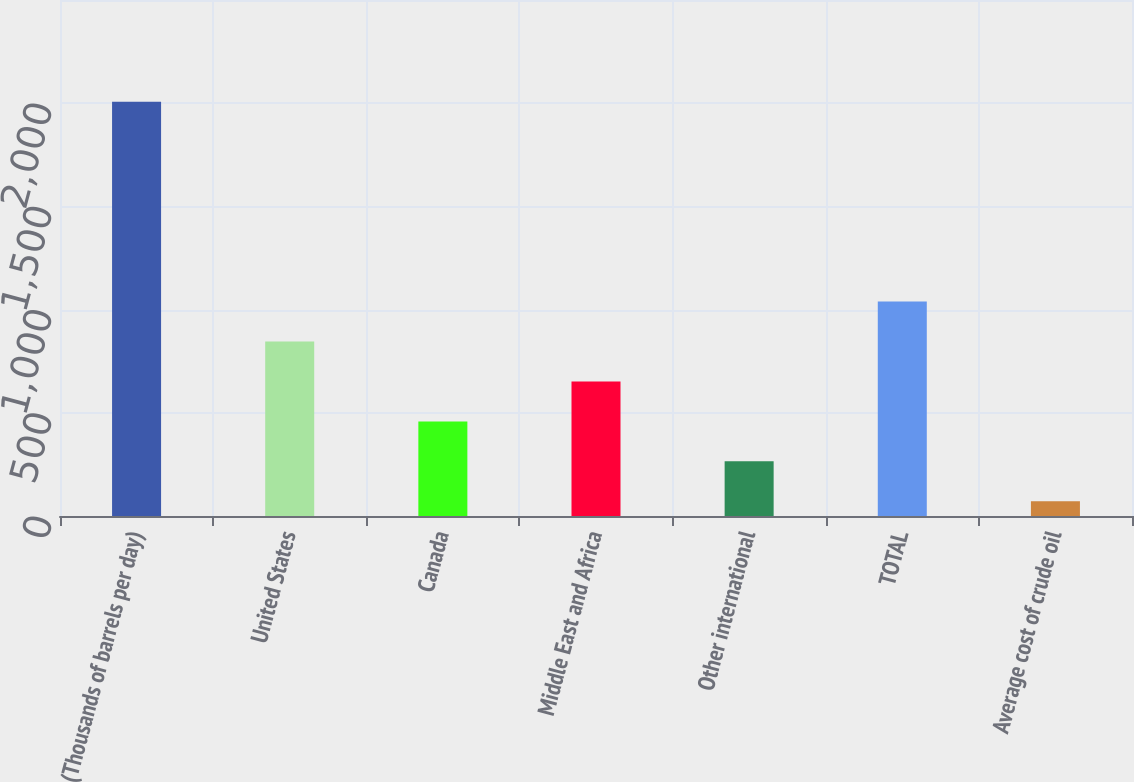Convert chart to OTSL. <chart><loc_0><loc_0><loc_500><loc_500><bar_chart><fcel>(Thousands of barrels per day)<fcel>United States<fcel>Canada<fcel>Middle East and Africa<fcel>Other international<fcel>TOTAL<fcel>Average cost of crude oil<nl><fcel>2007<fcel>845.52<fcel>458.36<fcel>651.94<fcel>264.78<fcel>1039.1<fcel>71.2<nl></chart> 